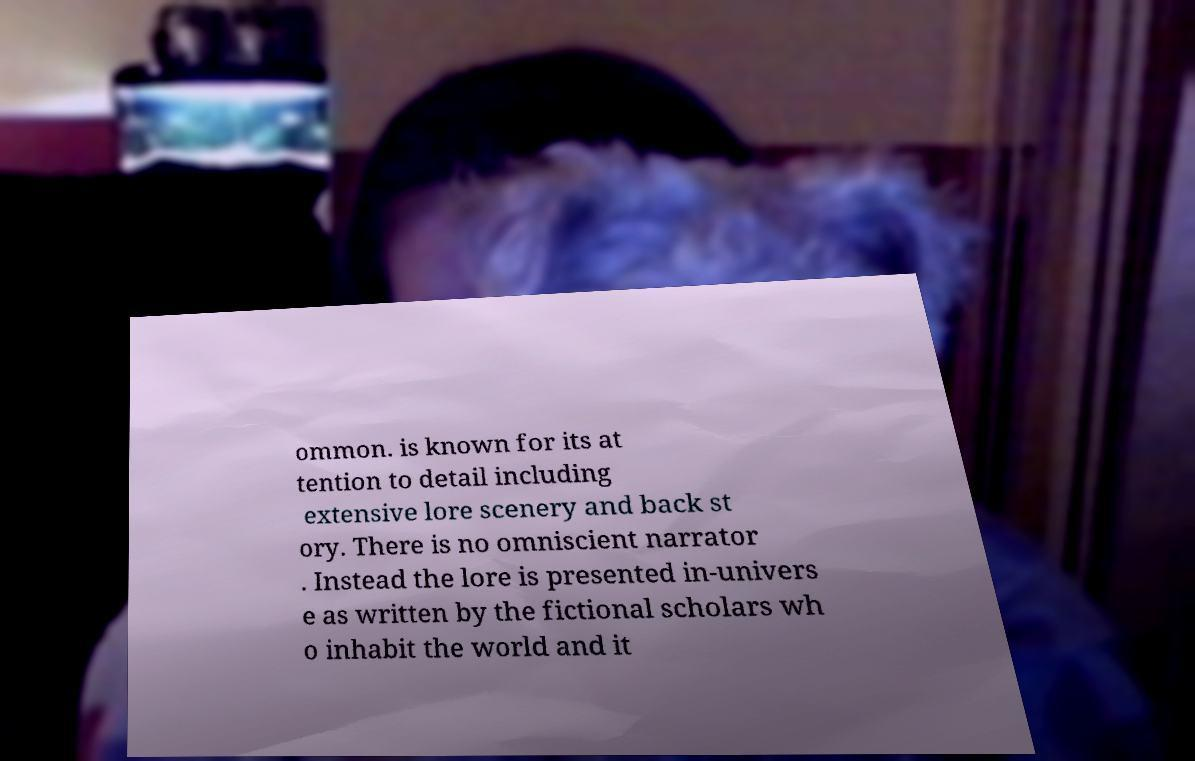What messages or text are displayed in this image? I need them in a readable, typed format. ommon. is known for its at tention to detail including extensive lore scenery and back st ory. There is no omniscient narrator . Instead the lore is presented in-univers e as written by the fictional scholars wh o inhabit the world and it 